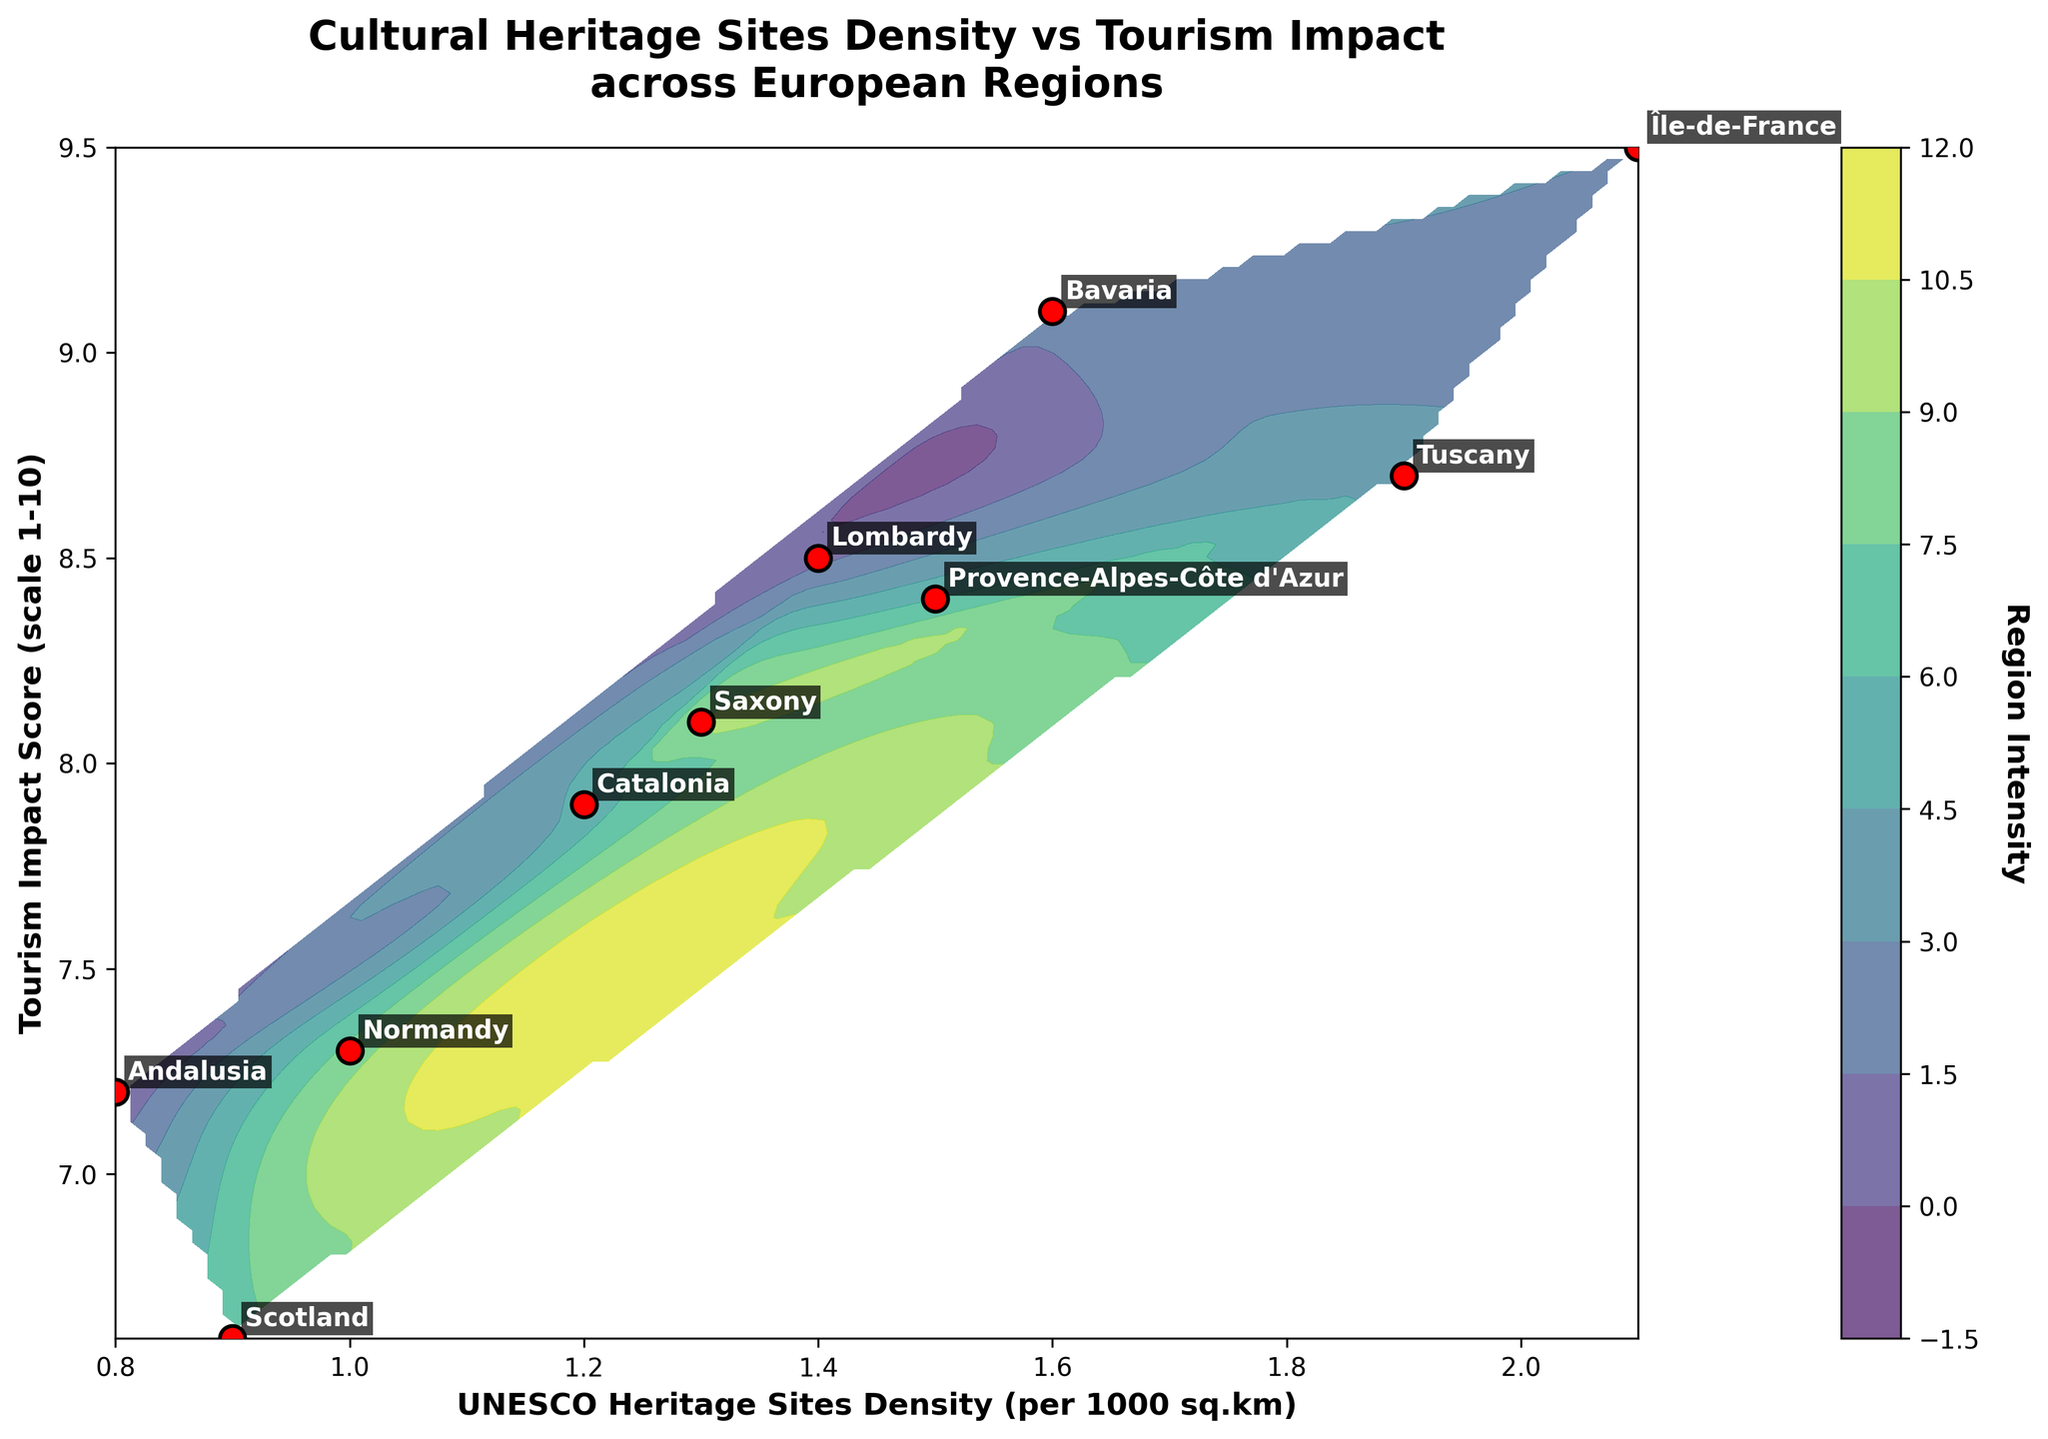What's the title of the plot? The title of the plot is typically found at the top center of most figures and is explicitly mentioned in the code.
Answer: Cultural Heritage Sites Density vs Tourism Impact across European Regions How many regions are represented in the plot? The number of regions can be determined by counting the scatter points or the annotated names in the plot, which are derived from the `regions` array.
Answer: 10 What is the highest UNESCO Heritage Sites Density value observed? This value can be found by identifying the highest x-coordinate among the scatter points.
Answer: 2.1 Which region has the highest Tourism Impact Score? By looking at the position of the scatter points on the y-axis and their corresponding labels, we can see which has the highest value.
Answer: Île-de-France Which region is positioned closest to the origin (0,0)? Identify the scatter point closest to the (0,0) mark by examining both x and y coordinates. Since none are close to (0,0), we consider the smallest combined distance.
Answer: Andalusia What is the average UNESCO Heritage Sites Density across all regions? Sum all the x-coordinates (UNESCO densities) and divide by the number of regions (10). Calculating: (0.8 + 1.4 + 1.6 + 2.1 + 1.9 + 1.2 + 1.5 + 0.9 + 1.0 + 1.3) / 10 = 13.7 / 10.
Answer: 1.37 Which two regions have the closest Tourism Impact Scores? Compare the y-coordinates (Tourism Impact Scores) of all regions to find the smallest difference.
Answer: Tuscany and Lombardy (both around 8.7 and 8.5) What is the range of the Tourism Impact Scores in the plot? The range is determined by subtracting the minimum y-coordinate from the maximum y-coordinate amongst the scatter points. The minimum is 6.6 and the maximum is 9.5, so 9.5 - 6.6.
Answer: 2.9 Which region is highlighted as an outlier in terms of high UNESCO Heritage Sites Density and low Tourism Impact Score? Identify the region that has significantly higher x and lower y coordinates compared to others.
Answer: Île-de-France 